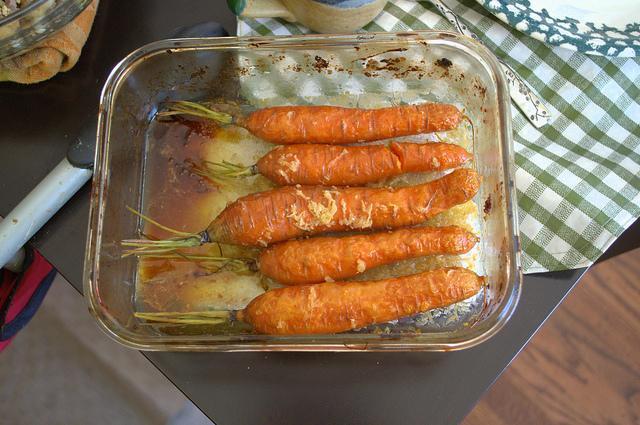Where did the food in the dish come from?
Indicate the correct response by choosing from the four available options to answer the question.
Options: Sky, ground, elephant waste, rock. Ground. 